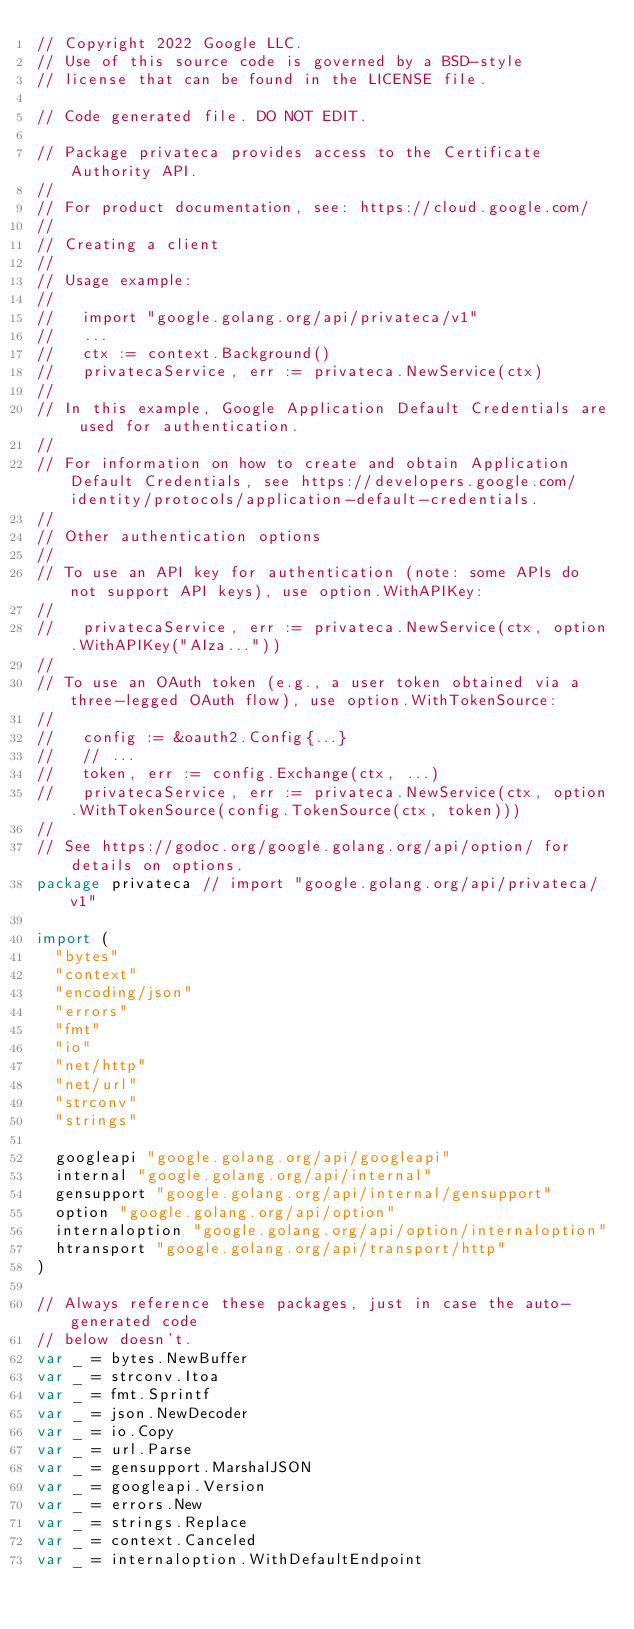<code> <loc_0><loc_0><loc_500><loc_500><_Go_>// Copyright 2022 Google LLC.
// Use of this source code is governed by a BSD-style
// license that can be found in the LICENSE file.

// Code generated file. DO NOT EDIT.

// Package privateca provides access to the Certificate Authority API.
//
// For product documentation, see: https://cloud.google.com/
//
// Creating a client
//
// Usage example:
//
//   import "google.golang.org/api/privateca/v1"
//   ...
//   ctx := context.Background()
//   privatecaService, err := privateca.NewService(ctx)
//
// In this example, Google Application Default Credentials are used for authentication.
//
// For information on how to create and obtain Application Default Credentials, see https://developers.google.com/identity/protocols/application-default-credentials.
//
// Other authentication options
//
// To use an API key for authentication (note: some APIs do not support API keys), use option.WithAPIKey:
//
//   privatecaService, err := privateca.NewService(ctx, option.WithAPIKey("AIza..."))
//
// To use an OAuth token (e.g., a user token obtained via a three-legged OAuth flow), use option.WithTokenSource:
//
//   config := &oauth2.Config{...}
//   // ...
//   token, err := config.Exchange(ctx, ...)
//   privatecaService, err := privateca.NewService(ctx, option.WithTokenSource(config.TokenSource(ctx, token)))
//
// See https://godoc.org/google.golang.org/api/option/ for details on options.
package privateca // import "google.golang.org/api/privateca/v1"

import (
	"bytes"
	"context"
	"encoding/json"
	"errors"
	"fmt"
	"io"
	"net/http"
	"net/url"
	"strconv"
	"strings"

	googleapi "google.golang.org/api/googleapi"
	internal "google.golang.org/api/internal"
	gensupport "google.golang.org/api/internal/gensupport"
	option "google.golang.org/api/option"
	internaloption "google.golang.org/api/option/internaloption"
	htransport "google.golang.org/api/transport/http"
)

// Always reference these packages, just in case the auto-generated code
// below doesn't.
var _ = bytes.NewBuffer
var _ = strconv.Itoa
var _ = fmt.Sprintf
var _ = json.NewDecoder
var _ = io.Copy
var _ = url.Parse
var _ = gensupport.MarshalJSON
var _ = googleapi.Version
var _ = errors.New
var _ = strings.Replace
var _ = context.Canceled
var _ = internaloption.WithDefaultEndpoint
</code> 